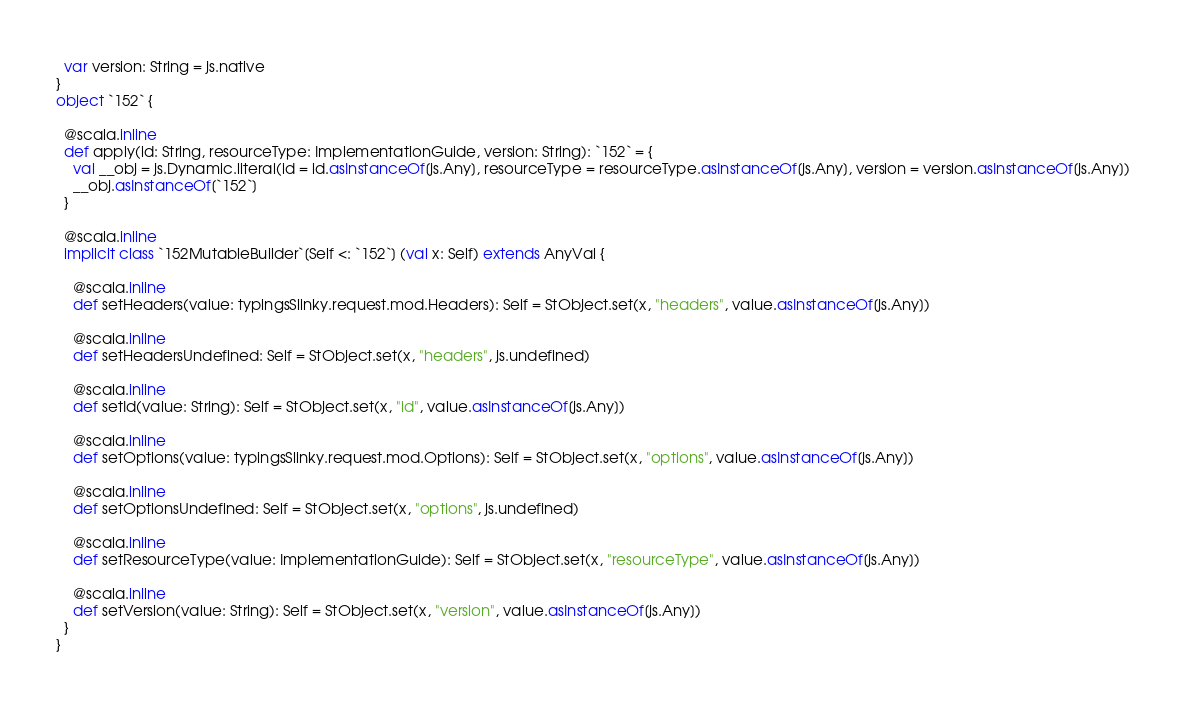<code> <loc_0><loc_0><loc_500><loc_500><_Scala_>  var version: String = js.native
}
object `152` {
  
  @scala.inline
  def apply(id: String, resourceType: ImplementationGuide, version: String): `152` = {
    val __obj = js.Dynamic.literal(id = id.asInstanceOf[js.Any], resourceType = resourceType.asInstanceOf[js.Any], version = version.asInstanceOf[js.Any])
    __obj.asInstanceOf[`152`]
  }
  
  @scala.inline
  implicit class `152MutableBuilder`[Self <: `152`] (val x: Self) extends AnyVal {
    
    @scala.inline
    def setHeaders(value: typingsSlinky.request.mod.Headers): Self = StObject.set(x, "headers", value.asInstanceOf[js.Any])
    
    @scala.inline
    def setHeadersUndefined: Self = StObject.set(x, "headers", js.undefined)
    
    @scala.inline
    def setId(value: String): Self = StObject.set(x, "id", value.asInstanceOf[js.Any])
    
    @scala.inline
    def setOptions(value: typingsSlinky.request.mod.Options): Self = StObject.set(x, "options", value.asInstanceOf[js.Any])
    
    @scala.inline
    def setOptionsUndefined: Self = StObject.set(x, "options", js.undefined)
    
    @scala.inline
    def setResourceType(value: ImplementationGuide): Self = StObject.set(x, "resourceType", value.asInstanceOf[js.Any])
    
    @scala.inline
    def setVersion(value: String): Self = StObject.set(x, "version", value.asInstanceOf[js.Any])
  }
}
</code> 